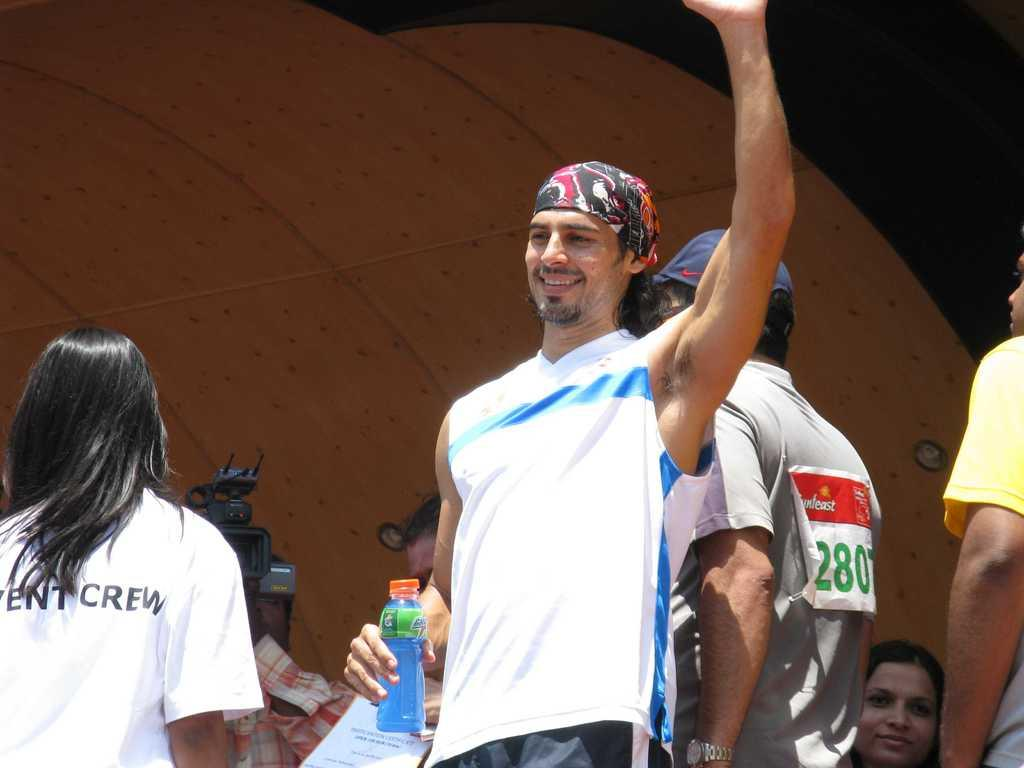How many people are in the image? There are persons standing in the image. What is one person holding in the image? One person is holding a bottle. Can you identify any object related to photography in the image? Yes, there is a camera visible in the image. What type of jewel is being used to expand the airplane in the image? There is no airplane, jewel, or expansion present in the image. 